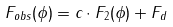Convert formula to latex. <formula><loc_0><loc_0><loc_500><loc_500>F _ { o b s } ( \phi ) = c \cdot F _ { 2 } ( \phi ) + F _ { d }</formula> 